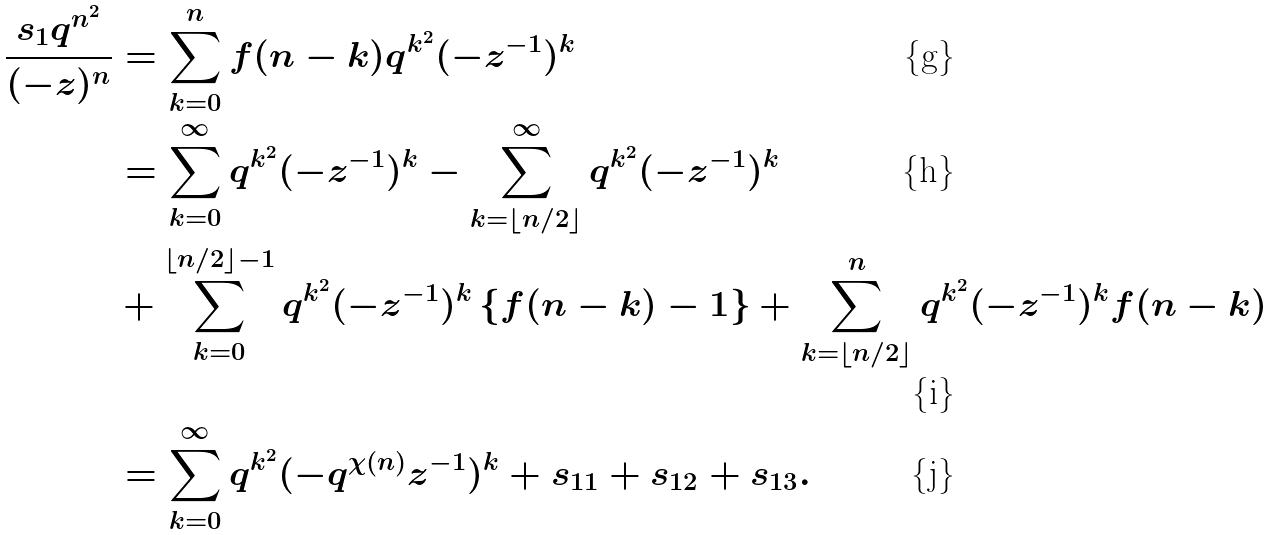<formula> <loc_0><loc_0><loc_500><loc_500>\frac { s _ { 1 } q ^ { n ^ { 2 } } } { ( - z ) ^ { n } } & = \sum _ { k = 0 } ^ { n } f ( n - k ) q ^ { k ^ { 2 } } ( - z ^ { - 1 } ) ^ { k } \\ & = \sum _ { k = 0 } ^ { \infty } q ^ { k ^ { 2 } } ( - z ^ { - 1 } ) ^ { k } - \sum _ { k = \left \lfloor n / 2 \right \rfloor } ^ { \infty } q ^ { k ^ { 2 } } ( - z ^ { - 1 } ) ^ { k } \\ & + \sum _ { k = 0 } ^ { \left \lfloor n / 2 \right \rfloor - 1 } q ^ { k ^ { 2 } } ( - z ^ { - 1 } ) ^ { k } \left \{ f ( n - k ) - 1 \right \} + \sum _ { k = \left \lfloor n / 2 \right \rfloor } ^ { n } q ^ { k ^ { 2 } } ( - z ^ { - 1 } ) ^ { k } f ( n - k ) \\ & = \sum _ { k = 0 } ^ { \infty } q ^ { k ^ { 2 } } ( - q ^ { \chi ( n ) } z ^ { - 1 } ) ^ { k } + s _ { 1 1 } + s _ { 1 2 } + s _ { 1 3 } .</formula> 